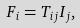Convert formula to latex. <formula><loc_0><loc_0><loc_500><loc_500>F _ { i } = T _ { i j } I _ { j } ,</formula> 